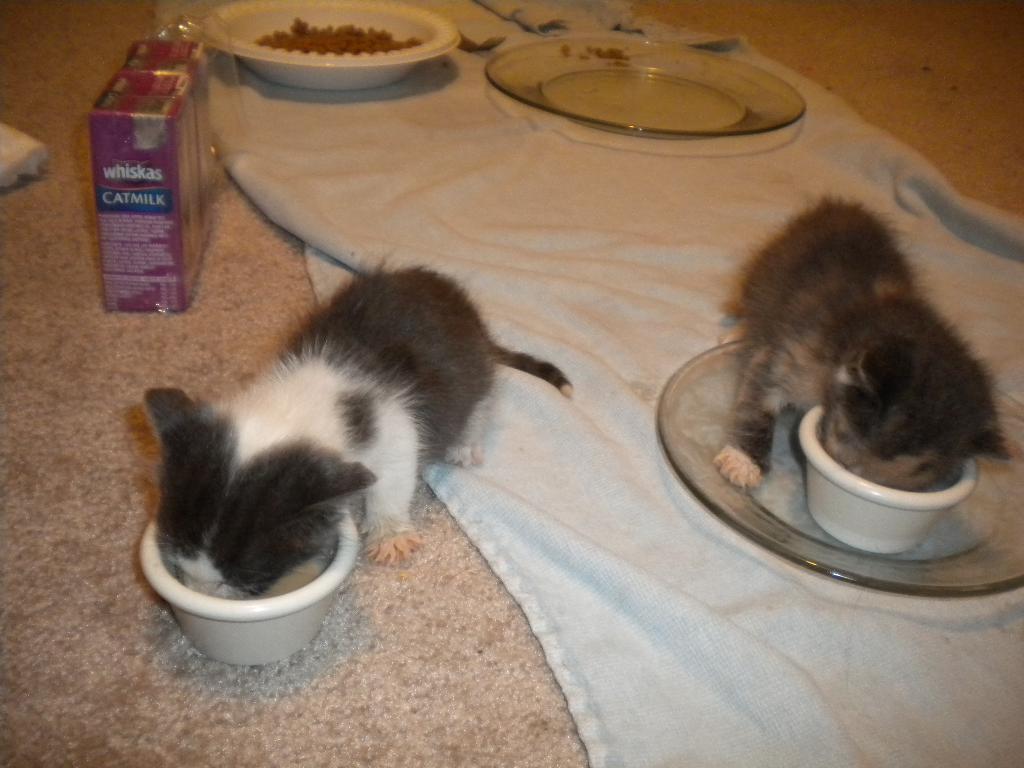Describe this image in one or two sentences. In this image on the floor there is a carpet, plates. Here is a packets. Two carts are eating. 